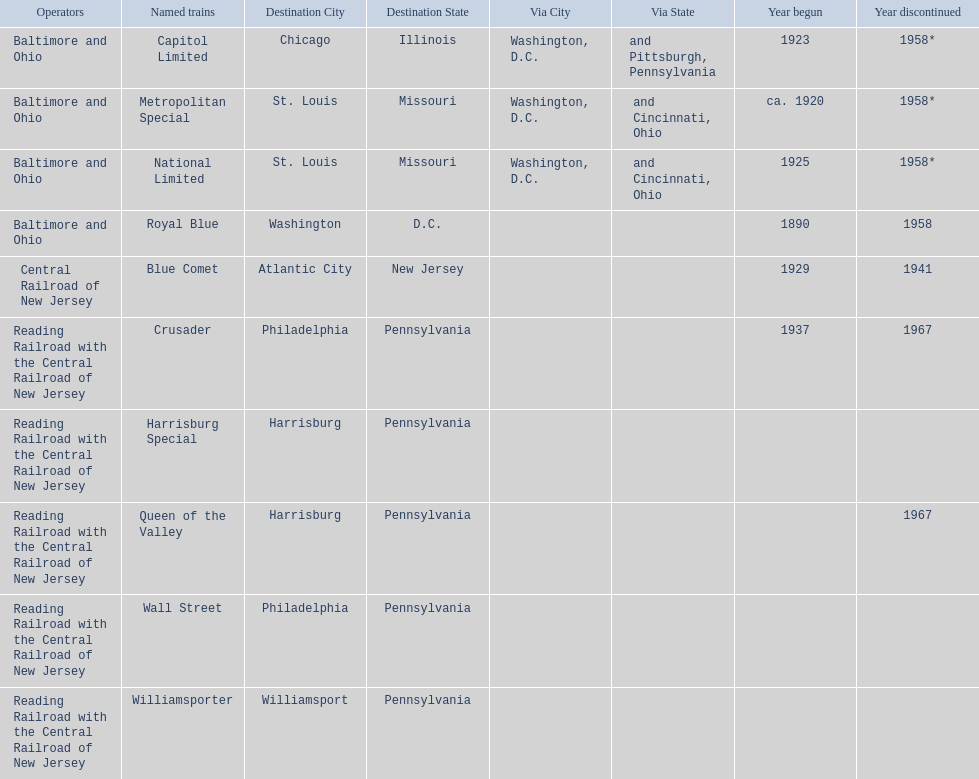What destinations are there? Chicago, Illinois via Washington, D.C. and Pittsburgh, Pennsylvania, St. Louis, Missouri via Washington, D.C. and Cincinnati, Ohio, St. Louis, Missouri via Washington, D.C. and Cincinnati, Ohio, Washington, D.C., Atlantic City, New Jersey, Philadelphia, Pennsylvania, Harrisburg, Pennsylvania, Harrisburg, Pennsylvania, Philadelphia, Pennsylvania, Williamsport, Pennsylvania. Which one is at the top of the list? Chicago, Illinois via Washington, D.C. and Pittsburgh, Pennsylvania. 